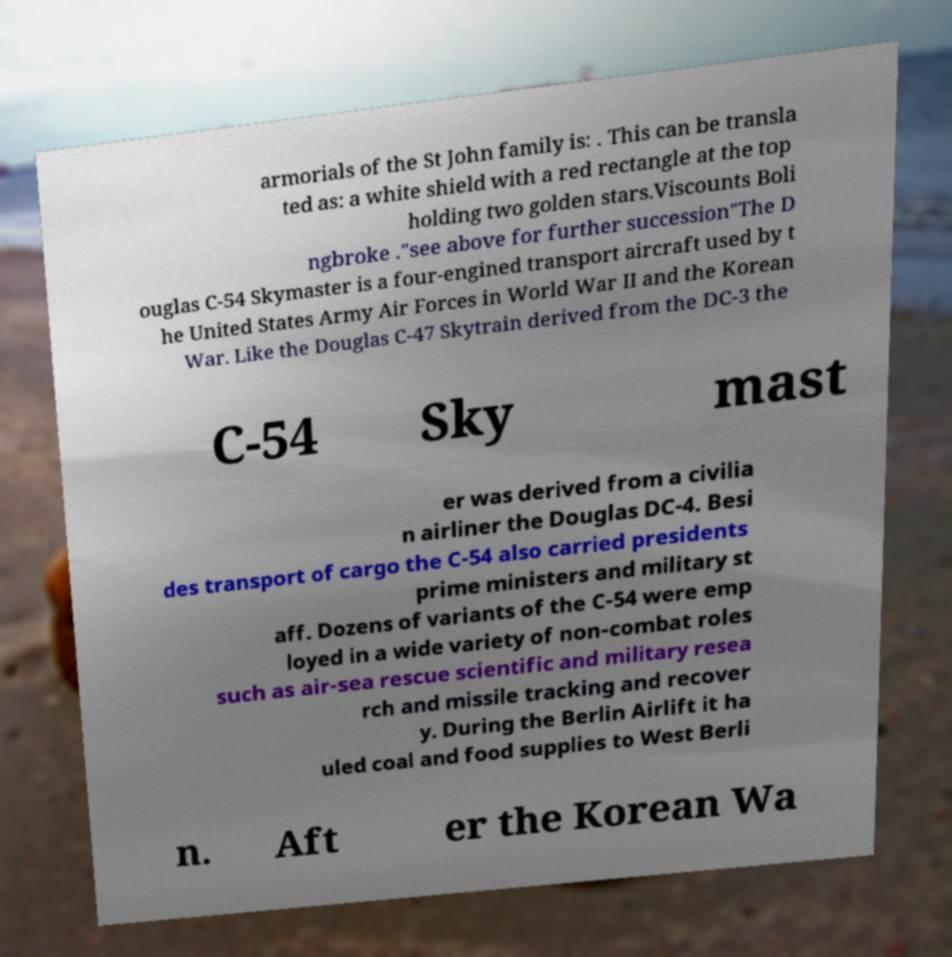Please identify and transcribe the text found in this image. armorials of the St John family is: . This can be transla ted as: a white shield with a red rectangle at the top holding two golden stars.Viscounts Boli ngbroke ."see above for further succession"The D ouglas C-54 Skymaster is a four-engined transport aircraft used by t he United States Army Air Forces in World War II and the Korean War. Like the Douglas C-47 Skytrain derived from the DC-3 the C-54 Sky mast er was derived from a civilia n airliner the Douglas DC-4. Besi des transport of cargo the C-54 also carried presidents prime ministers and military st aff. Dozens of variants of the C-54 were emp loyed in a wide variety of non-combat roles such as air-sea rescue scientific and military resea rch and missile tracking and recover y. During the Berlin Airlift it ha uled coal and food supplies to West Berli n. Aft er the Korean Wa 